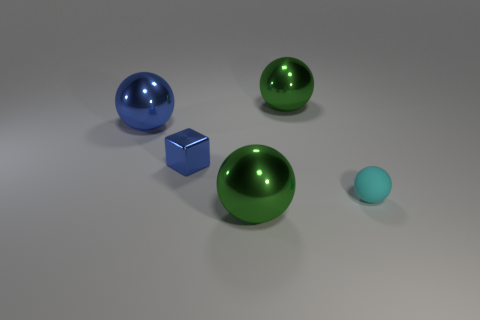If the objects in the image were part of a set, which one doesn't belong? Assuming the set is defined by shape, the cube would be the outlier, as it's the only object with a geometric shape that has edges and corners, while the others are spherical. If the set is based on material properties, then the tiny ball doesn't belong because it has a matte finish unlike the reflective surfaces of the other objects. 